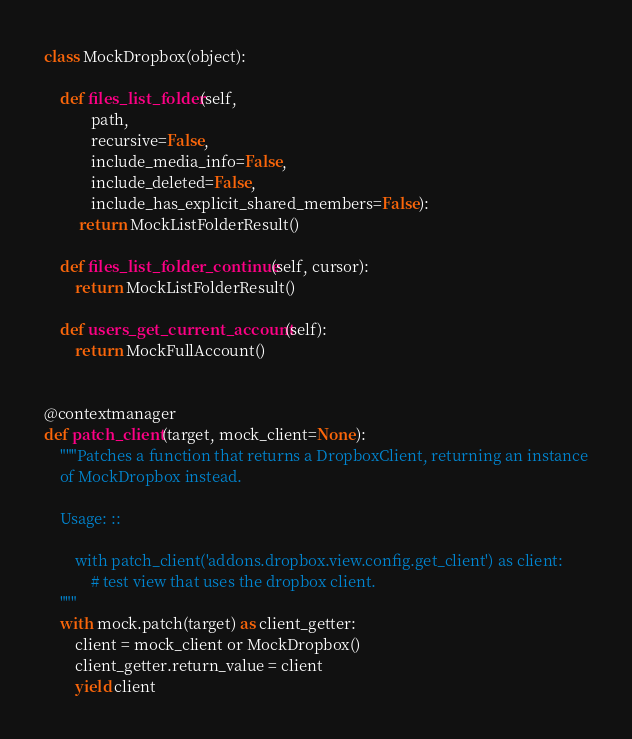Convert code to text. <code><loc_0><loc_0><loc_500><loc_500><_Python_>

class MockDropbox(object):

    def files_list_folder(self,
            path,
            recursive=False,
            include_media_info=False,
            include_deleted=False,
            include_has_explicit_shared_members=False):
         return MockListFolderResult()

    def files_list_folder_continue(self, cursor):
        return MockListFolderResult()

    def users_get_current_account(self):
        return MockFullAccount()


@contextmanager
def patch_client(target, mock_client=None):
    """Patches a function that returns a DropboxClient, returning an instance
    of MockDropbox instead.

    Usage: ::

        with patch_client('addons.dropbox.view.config.get_client') as client:
            # test view that uses the dropbox client.
    """
    with mock.patch(target) as client_getter:
        client = mock_client or MockDropbox()
        client_getter.return_value = client
        yield client
</code> 